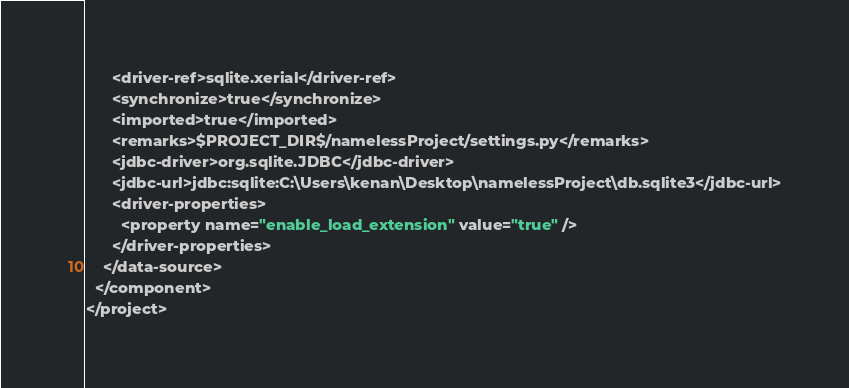Convert code to text. <code><loc_0><loc_0><loc_500><loc_500><_XML_>      <driver-ref>sqlite.xerial</driver-ref>
      <synchronize>true</synchronize>
      <imported>true</imported>
      <remarks>$PROJECT_DIR$/namelessProject/settings.py</remarks>
      <jdbc-driver>org.sqlite.JDBC</jdbc-driver>
      <jdbc-url>jdbc:sqlite:C:\Users\kenan\Desktop\namelessProject\db.sqlite3</jdbc-url>
      <driver-properties>
        <property name="enable_load_extension" value="true" />
      </driver-properties>
    </data-source>
  </component>
</project></code> 